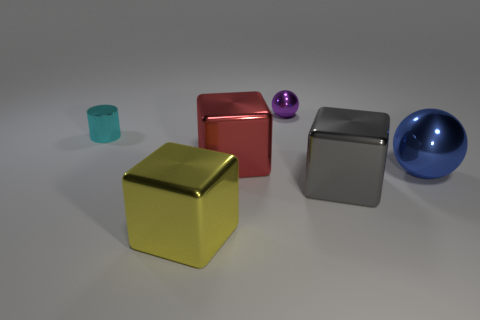Subtract all gray shiny cubes. How many cubes are left? 2 Subtract all spheres. How many objects are left? 4 Subtract all green blocks. Subtract all purple balls. How many blocks are left? 3 Subtract all blue cylinders. How many purple spheres are left? 1 Subtract all purple objects. Subtract all large yellow blocks. How many objects are left? 4 Add 2 big yellow metal blocks. How many big yellow metal blocks are left? 3 Add 5 small metal objects. How many small metal objects exist? 7 Add 1 tiny metal balls. How many objects exist? 7 Subtract all red cubes. How many cubes are left? 2 Subtract 0 gray cylinders. How many objects are left? 6 